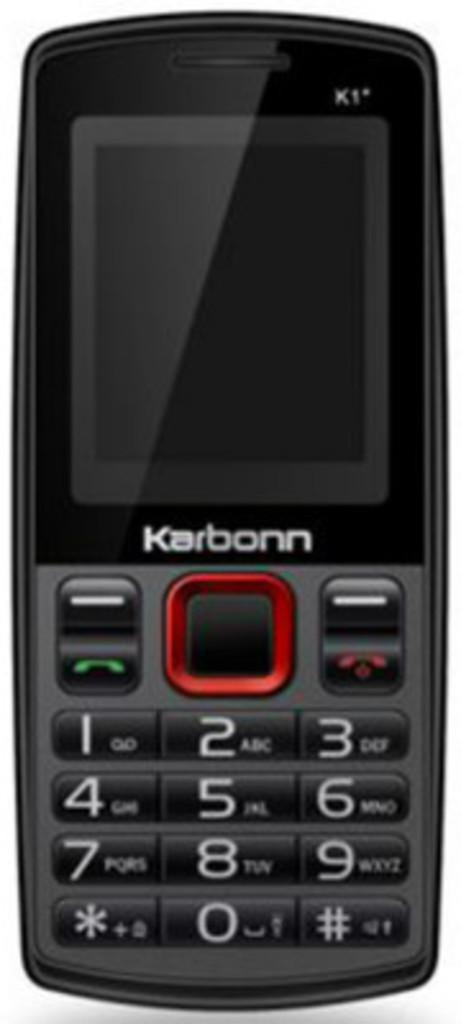Provide a one-sentence caption for the provided image. A small black cellaphone by the brand Karbonn. 